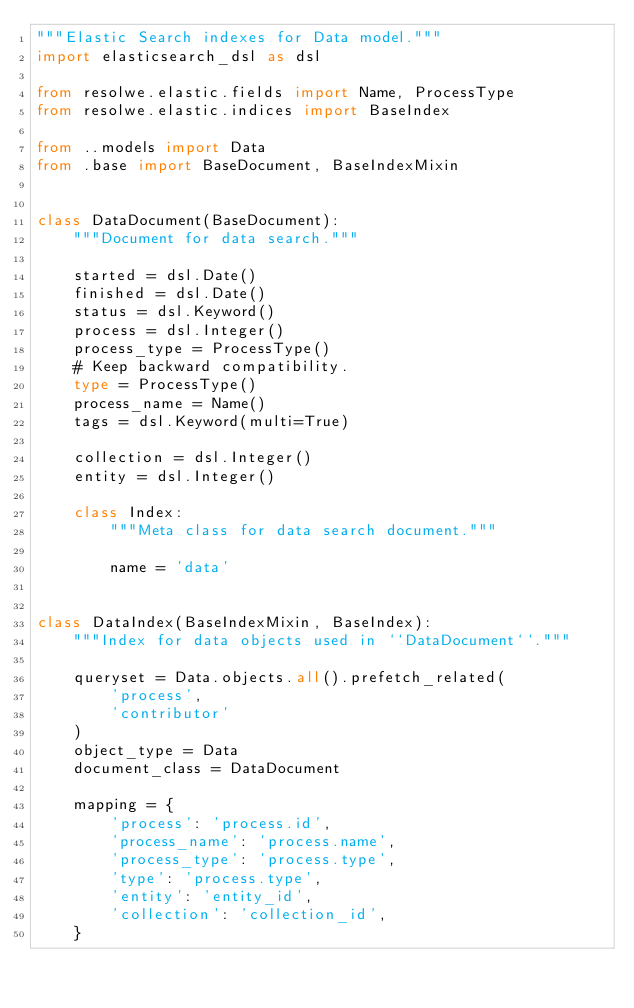<code> <loc_0><loc_0><loc_500><loc_500><_Python_>"""Elastic Search indexes for Data model."""
import elasticsearch_dsl as dsl

from resolwe.elastic.fields import Name, ProcessType
from resolwe.elastic.indices import BaseIndex

from ..models import Data
from .base import BaseDocument, BaseIndexMixin


class DataDocument(BaseDocument):
    """Document for data search."""

    started = dsl.Date()
    finished = dsl.Date()
    status = dsl.Keyword()
    process = dsl.Integer()
    process_type = ProcessType()
    # Keep backward compatibility.
    type = ProcessType()
    process_name = Name()
    tags = dsl.Keyword(multi=True)

    collection = dsl.Integer()
    entity = dsl.Integer()

    class Index:
        """Meta class for data search document."""

        name = 'data'


class DataIndex(BaseIndexMixin, BaseIndex):
    """Index for data objects used in ``DataDocument``."""

    queryset = Data.objects.all().prefetch_related(
        'process',
        'contributor'
    )
    object_type = Data
    document_class = DataDocument

    mapping = {
        'process': 'process.id',
        'process_name': 'process.name',
        'process_type': 'process.type',
        'type': 'process.type',
        'entity': 'entity_id',
        'collection': 'collection_id',
    }
</code> 